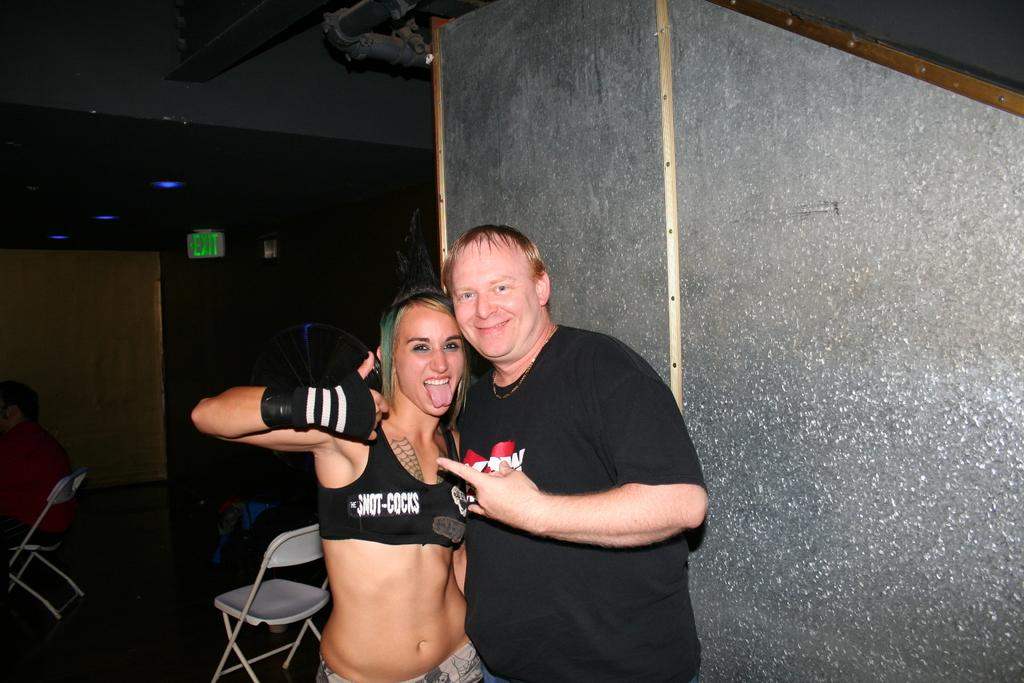How many people are present in the image? There are two people standing in the image. What is located beside the people? There is a wall beside the people. What can be seen in the background of the image? The background of the image is dark, and there are chairs, people, and a board visible. What is the distribution of time in the image? The concept of time distribution is not applicable to the image, as it is a static representation and does not depict the passage of time. 